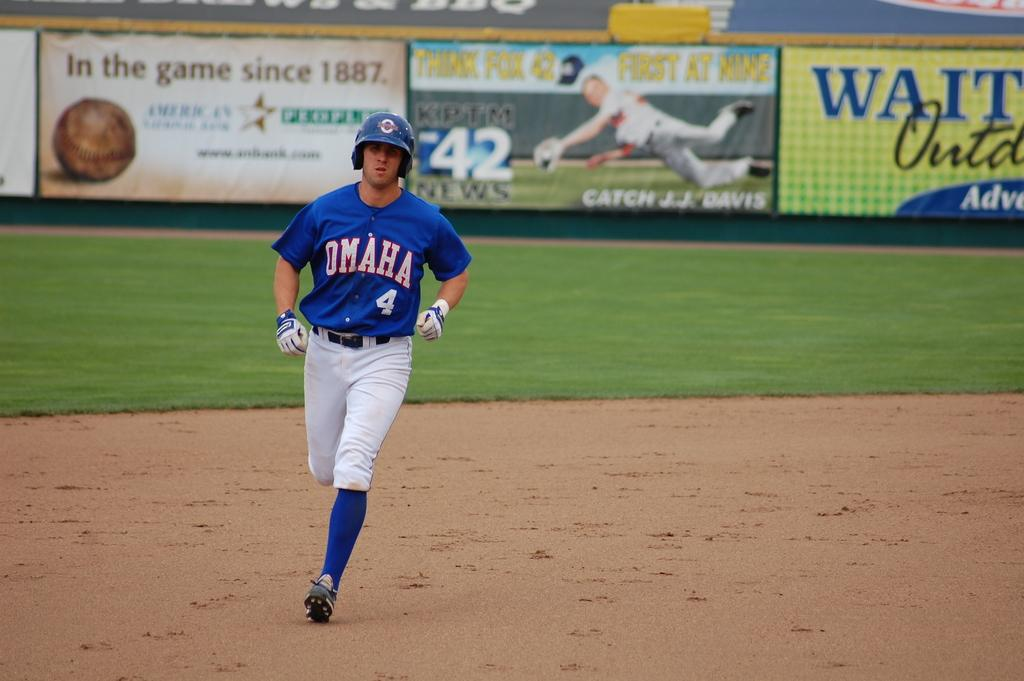<image>
Share a concise interpretation of the image provided. A baseball player for Omaha is running for a base. 